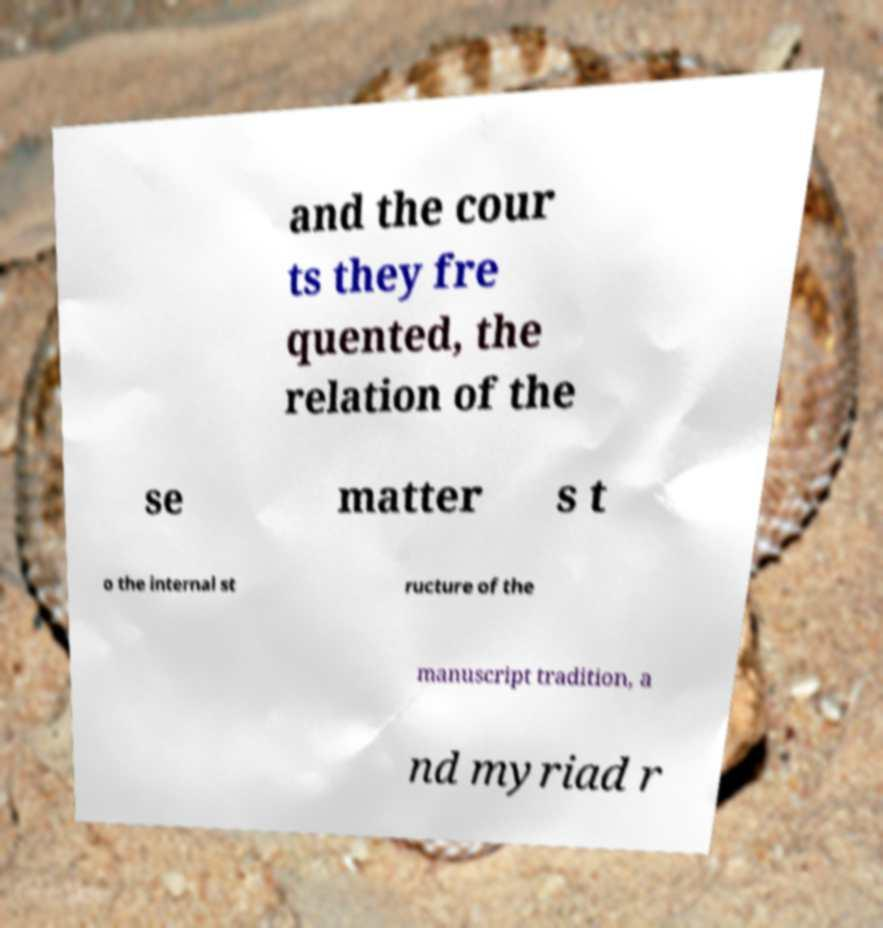Could you extract and type out the text from this image? and the cour ts they fre quented, the relation of the se matter s t o the internal st ructure of the manuscript tradition, a nd myriad r 